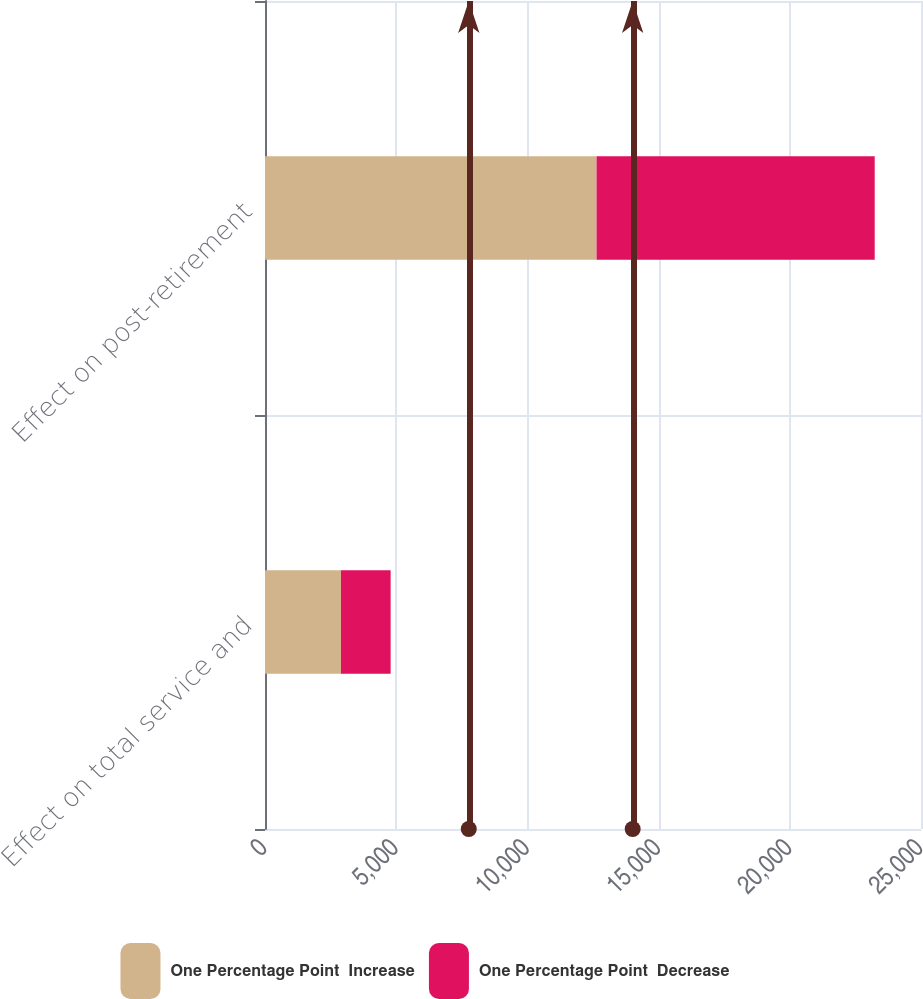<chart> <loc_0><loc_0><loc_500><loc_500><stacked_bar_chart><ecel><fcel>Effect on total service and<fcel>Effect on post-retirement<nl><fcel>One Percentage Point  Increase<fcel>2896<fcel>12636<nl><fcel>One Percentage Point  Decrease<fcel>1892<fcel>10600<nl></chart> 